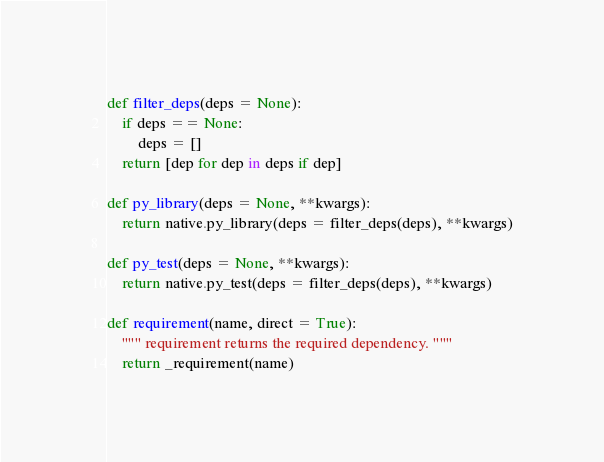Convert code to text. <code><loc_0><loc_0><loc_500><loc_500><_Python_>def filter_deps(deps = None):
    if deps == None:
        deps = []
    return [dep for dep in deps if dep]

def py_library(deps = None, **kwargs):
    return native.py_library(deps = filter_deps(deps), **kwargs)

def py_test(deps = None, **kwargs):
    return native.py_test(deps = filter_deps(deps), **kwargs)

def requirement(name, direct = True):
    """ requirement returns the required dependency. """
    return _requirement(name)
</code> 